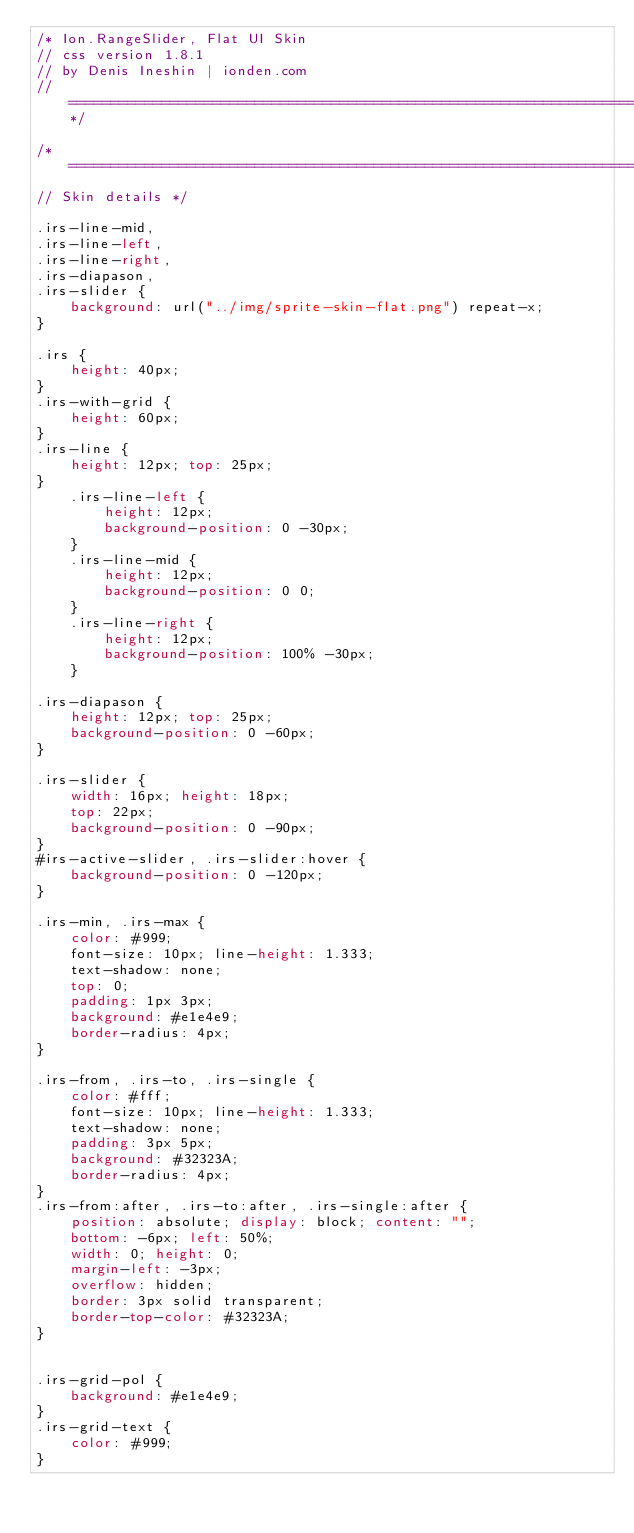Convert code to text. <code><loc_0><loc_0><loc_500><loc_500><_CSS_>/* Ion.RangeSlider, Flat UI Skin
// css version 1.8.1
// by Denis Ineshin | ionden.com
// ===================================================================================================================*/

/* =====================================================================================================================
// Skin details */

.irs-line-mid,
.irs-line-left,
.irs-line-right,
.irs-diapason,
.irs-slider {
    background: url("../img/sprite-skin-flat.png") repeat-x;
}

.irs {
    height: 40px;
}
.irs-with-grid {
    height: 60px;
}
.irs-line {
    height: 12px; top: 25px;
}
    .irs-line-left {
        height: 12px;
        background-position: 0 -30px;
    }
    .irs-line-mid {
        height: 12px;
        background-position: 0 0;
    }
    .irs-line-right {
        height: 12px;
        background-position: 100% -30px;
    }

.irs-diapason {
    height: 12px; top: 25px;
    background-position: 0 -60px;
}

.irs-slider {
    width: 16px; height: 18px;
    top: 22px;
    background-position: 0 -90px;
}
#irs-active-slider, .irs-slider:hover {
    background-position: 0 -120px;
}

.irs-min, .irs-max {
    color: #999;
    font-size: 10px; line-height: 1.333;
    text-shadow: none;
    top: 0;
    padding: 1px 3px;
    background: #e1e4e9;
    border-radius: 4px;
}

.irs-from, .irs-to, .irs-single {
    color: #fff;
    font-size: 10px; line-height: 1.333;
    text-shadow: none;
    padding: 3px 5px;
    background: #32323A;
    border-radius: 4px;
}
.irs-from:after, .irs-to:after, .irs-single:after {
    position: absolute; display: block; content: "";
    bottom: -6px; left: 50%;
    width: 0; height: 0;
    margin-left: -3px;
    overflow: hidden;
    border: 3px solid transparent;
    border-top-color: #32323A;
}


.irs-grid-pol {
    background: #e1e4e9;
}
.irs-grid-text {
    color: #999;
}</code> 